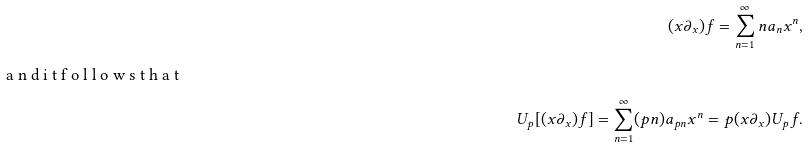<formula> <loc_0><loc_0><loc_500><loc_500>( x \partial _ { x } ) f = \sum _ { n = 1 } ^ { \infty } n a _ { n } x ^ { n } , \intertext { a n d i t f o l l o w s t h a t } U _ { p } [ ( x \partial _ { x } ) f ] = \sum _ { n = 1 } ^ { \infty } ( p n ) a _ { p n } x ^ { n } = p ( x \partial _ { x } ) U _ { p } f .</formula> 